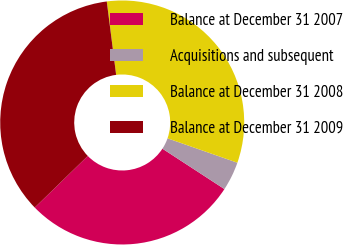Convert chart to OTSL. <chart><loc_0><loc_0><loc_500><loc_500><pie_chart><fcel>Balance at December 31 2007<fcel>Acquisitions and subsequent<fcel>Balance at December 31 2008<fcel>Balance at December 31 2009<nl><fcel>28.53%<fcel>3.84%<fcel>32.37%<fcel>35.26%<nl></chart> 